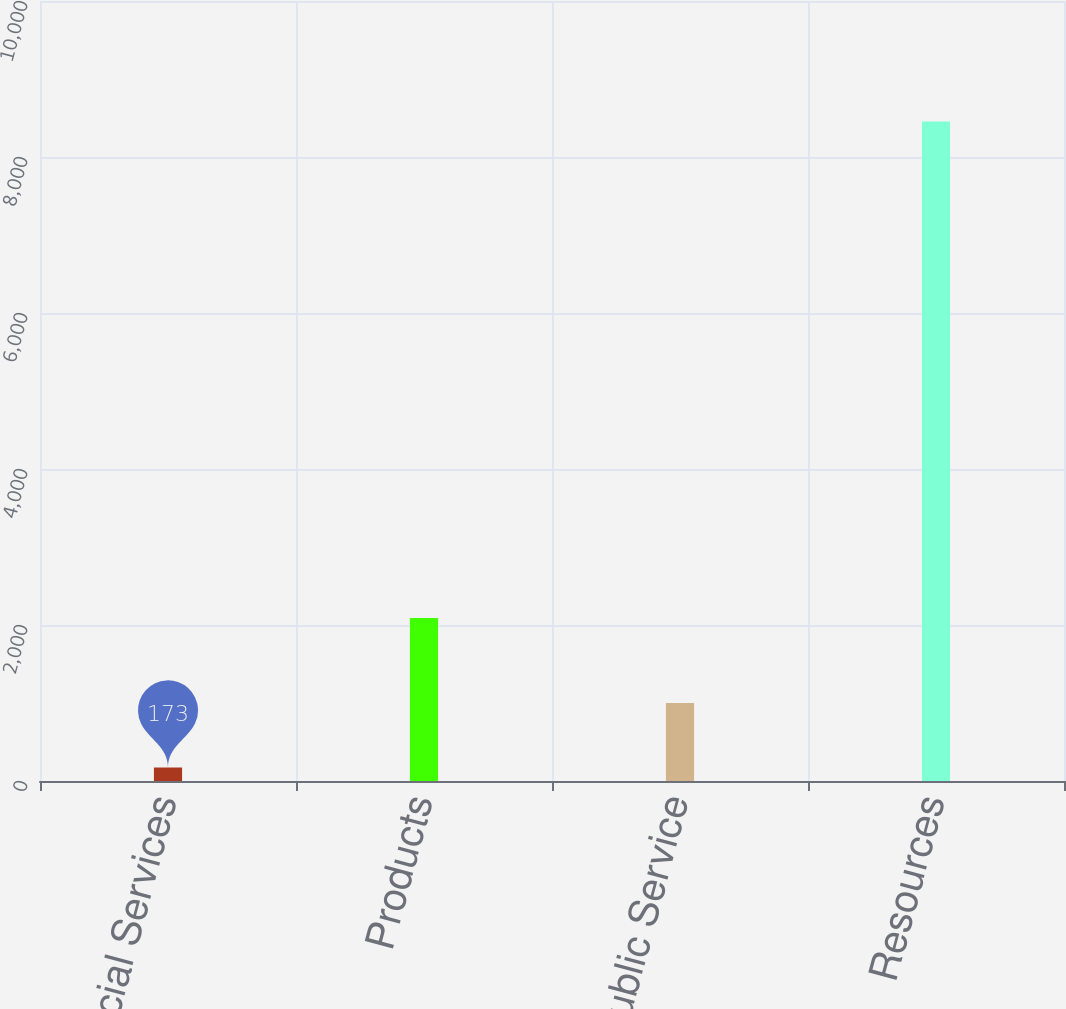Convert chart to OTSL. <chart><loc_0><loc_0><loc_500><loc_500><bar_chart><fcel>Financial Services<fcel>Products<fcel>Public Service<fcel>Resources<nl><fcel>173<fcel>2090<fcel>1001.2<fcel>8455<nl></chart> 